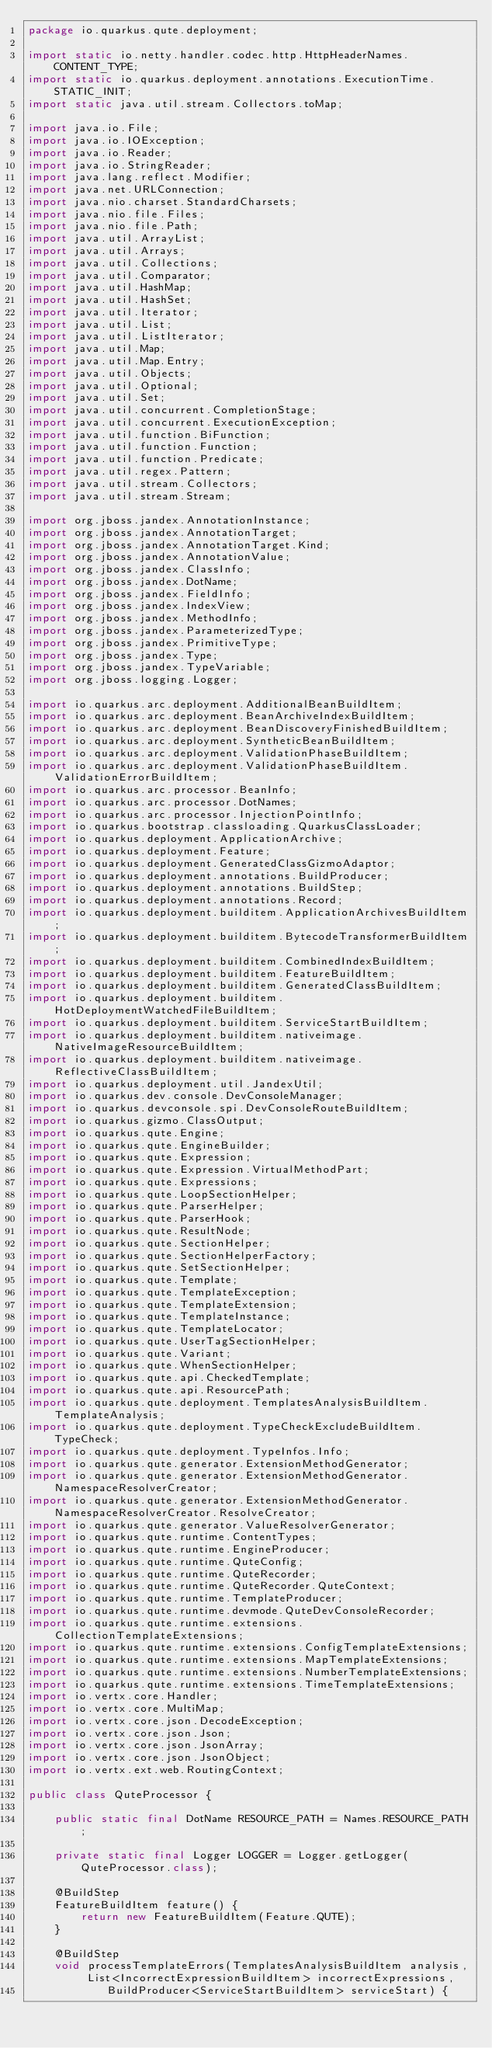Convert code to text. <code><loc_0><loc_0><loc_500><loc_500><_Java_>package io.quarkus.qute.deployment;

import static io.netty.handler.codec.http.HttpHeaderNames.CONTENT_TYPE;
import static io.quarkus.deployment.annotations.ExecutionTime.STATIC_INIT;
import static java.util.stream.Collectors.toMap;

import java.io.File;
import java.io.IOException;
import java.io.Reader;
import java.io.StringReader;
import java.lang.reflect.Modifier;
import java.net.URLConnection;
import java.nio.charset.StandardCharsets;
import java.nio.file.Files;
import java.nio.file.Path;
import java.util.ArrayList;
import java.util.Arrays;
import java.util.Collections;
import java.util.Comparator;
import java.util.HashMap;
import java.util.HashSet;
import java.util.Iterator;
import java.util.List;
import java.util.ListIterator;
import java.util.Map;
import java.util.Map.Entry;
import java.util.Objects;
import java.util.Optional;
import java.util.Set;
import java.util.concurrent.CompletionStage;
import java.util.concurrent.ExecutionException;
import java.util.function.BiFunction;
import java.util.function.Function;
import java.util.function.Predicate;
import java.util.regex.Pattern;
import java.util.stream.Collectors;
import java.util.stream.Stream;

import org.jboss.jandex.AnnotationInstance;
import org.jboss.jandex.AnnotationTarget;
import org.jboss.jandex.AnnotationTarget.Kind;
import org.jboss.jandex.AnnotationValue;
import org.jboss.jandex.ClassInfo;
import org.jboss.jandex.DotName;
import org.jboss.jandex.FieldInfo;
import org.jboss.jandex.IndexView;
import org.jboss.jandex.MethodInfo;
import org.jboss.jandex.ParameterizedType;
import org.jboss.jandex.PrimitiveType;
import org.jboss.jandex.Type;
import org.jboss.jandex.TypeVariable;
import org.jboss.logging.Logger;

import io.quarkus.arc.deployment.AdditionalBeanBuildItem;
import io.quarkus.arc.deployment.BeanArchiveIndexBuildItem;
import io.quarkus.arc.deployment.BeanDiscoveryFinishedBuildItem;
import io.quarkus.arc.deployment.SyntheticBeanBuildItem;
import io.quarkus.arc.deployment.ValidationPhaseBuildItem;
import io.quarkus.arc.deployment.ValidationPhaseBuildItem.ValidationErrorBuildItem;
import io.quarkus.arc.processor.BeanInfo;
import io.quarkus.arc.processor.DotNames;
import io.quarkus.arc.processor.InjectionPointInfo;
import io.quarkus.bootstrap.classloading.QuarkusClassLoader;
import io.quarkus.deployment.ApplicationArchive;
import io.quarkus.deployment.Feature;
import io.quarkus.deployment.GeneratedClassGizmoAdaptor;
import io.quarkus.deployment.annotations.BuildProducer;
import io.quarkus.deployment.annotations.BuildStep;
import io.quarkus.deployment.annotations.Record;
import io.quarkus.deployment.builditem.ApplicationArchivesBuildItem;
import io.quarkus.deployment.builditem.BytecodeTransformerBuildItem;
import io.quarkus.deployment.builditem.CombinedIndexBuildItem;
import io.quarkus.deployment.builditem.FeatureBuildItem;
import io.quarkus.deployment.builditem.GeneratedClassBuildItem;
import io.quarkus.deployment.builditem.HotDeploymentWatchedFileBuildItem;
import io.quarkus.deployment.builditem.ServiceStartBuildItem;
import io.quarkus.deployment.builditem.nativeimage.NativeImageResourceBuildItem;
import io.quarkus.deployment.builditem.nativeimage.ReflectiveClassBuildItem;
import io.quarkus.deployment.util.JandexUtil;
import io.quarkus.dev.console.DevConsoleManager;
import io.quarkus.devconsole.spi.DevConsoleRouteBuildItem;
import io.quarkus.gizmo.ClassOutput;
import io.quarkus.qute.Engine;
import io.quarkus.qute.EngineBuilder;
import io.quarkus.qute.Expression;
import io.quarkus.qute.Expression.VirtualMethodPart;
import io.quarkus.qute.Expressions;
import io.quarkus.qute.LoopSectionHelper;
import io.quarkus.qute.ParserHelper;
import io.quarkus.qute.ParserHook;
import io.quarkus.qute.ResultNode;
import io.quarkus.qute.SectionHelper;
import io.quarkus.qute.SectionHelperFactory;
import io.quarkus.qute.SetSectionHelper;
import io.quarkus.qute.Template;
import io.quarkus.qute.TemplateException;
import io.quarkus.qute.TemplateExtension;
import io.quarkus.qute.TemplateInstance;
import io.quarkus.qute.TemplateLocator;
import io.quarkus.qute.UserTagSectionHelper;
import io.quarkus.qute.Variant;
import io.quarkus.qute.WhenSectionHelper;
import io.quarkus.qute.api.CheckedTemplate;
import io.quarkus.qute.api.ResourcePath;
import io.quarkus.qute.deployment.TemplatesAnalysisBuildItem.TemplateAnalysis;
import io.quarkus.qute.deployment.TypeCheckExcludeBuildItem.TypeCheck;
import io.quarkus.qute.deployment.TypeInfos.Info;
import io.quarkus.qute.generator.ExtensionMethodGenerator;
import io.quarkus.qute.generator.ExtensionMethodGenerator.NamespaceResolverCreator;
import io.quarkus.qute.generator.ExtensionMethodGenerator.NamespaceResolverCreator.ResolveCreator;
import io.quarkus.qute.generator.ValueResolverGenerator;
import io.quarkus.qute.runtime.ContentTypes;
import io.quarkus.qute.runtime.EngineProducer;
import io.quarkus.qute.runtime.QuteConfig;
import io.quarkus.qute.runtime.QuteRecorder;
import io.quarkus.qute.runtime.QuteRecorder.QuteContext;
import io.quarkus.qute.runtime.TemplateProducer;
import io.quarkus.qute.runtime.devmode.QuteDevConsoleRecorder;
import io.quarkus.qute.runtime.extensions.CollectionTemplateExtensions;
import io.quarkus.qute.runtime.extensions.ConfigTemplateExtensions;
import io.quarkus.qute.runtime.extensions.MapTemplateExtensions;
import io.quarkus.qute.runtime.extensions.NumberTemplateExtensions;
import io.quarkus.qute.runtime.extensions.TimeTemplateExtensions;
import io.vertx.core.Handler;
import io.vertx.core.MultiMap;
import io.vertx.core.json.DecodeException;
import io.vertx.core.json.Json;
import io.vertx.core.json.JsonArray;
import io.vertx.core.json.JsonObject;
import io.vertx.ext.web.RoutingContext;

public class QuteProcessor {

    public static final DotName RESOURCE_PATH = Names.RESOURCE_PATH;

    private static final Logger LOGGER = Logger.getLogger(QuteProcessor.class);

    @BuildStep
    FeatureBuildItem feature() {
        return new FeatureBuildItem(Feature.QUTE);
    }

    @BuildStep
    void processTemplateErrors(TemplatesAnalysisBuildItem analysis, List<IncorrectExpressionBuildItem> incorrectExpressions,
            BuildProducer<ServiceStartBuildItem> serviceStart) {
</code> 